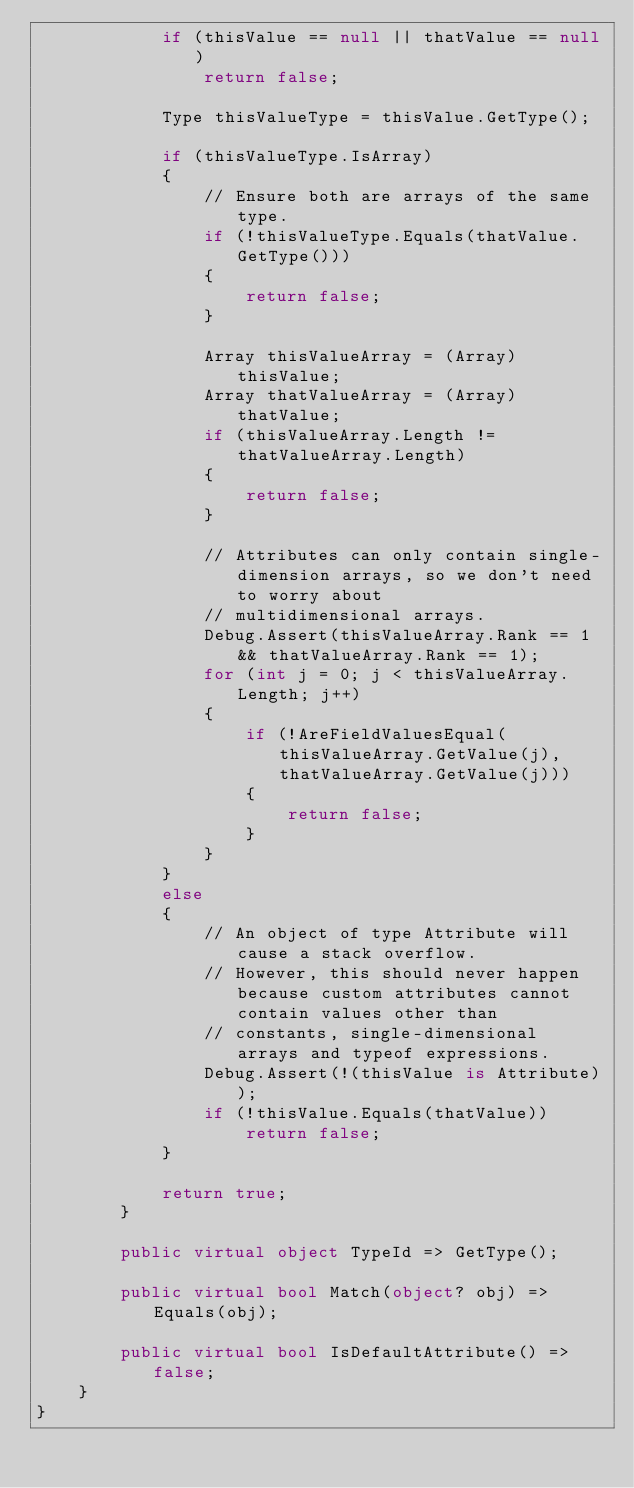Convert code to text. <code><loc_0><loc_0><loc_500><loc_500><_C#_>            if (thisValue == null || thatValue == null)
                return false;

            Type thisValueType = thisValue.GetType();

            if (thisValueType.IsArray)
            {
                // Ensure both are arrays of the same type.
                if (!thisValueType.Equals(thatValue.GetType()))
                {
                    return false;
                }

                Array thisValueArray = (Array)thisValue;
                Array thatValueArray = (Array)thatValue;
                if (thisValueArray.Length != thatValueArray.Length)
                {
                    return false;
                }

                // Attributes can only contain single-dimension arrays, so we don't need to worry about
                // multidimensional arrays.
                Debug.Assert(thisValueArray.Rank == 1 && thatValueArray.Rank == 1);
                for (int j = 0; j < thisValueArray.Length; j++)
                {
                    if (!AreFieldValuesEqual(thisValueArray.GetValue(j), thatValueArray.GetValue(j)))
                    {
                        return false;
                    }
                }
            }
            else
            {
                // An object of type Attribute will cause a stack overflow.
                // However, this should never happen because custom attributes cannot contain values other than
                // constants, single-dimensional arrays and typeof expressions.
                Debug.Assert(!(thisValue is Attribute));
                if (!thisValue.Equals(thatValue))
                    return false;
            }

            return true;
        }

        public virtual object TypeId => GetType();

        public virtual bool Match(object? obj) => Equals(obj);

        public virtual bool IsDefaultAttribute() => false;
    }
}
</code> 